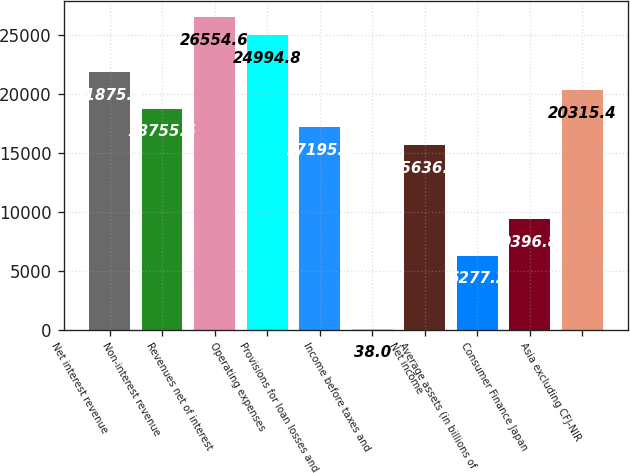Convert chart. <chart><loc_0><loc_0><loc_500><loc_500><bar_chart><fcel>Net interest revenue<fcel>Non-interest revenue<fcel>Revenues net of interest<fcel>Operating expenses<fcel>Provisions for loan losses and<fcel>Income before taxes and<fcel>Net income<fcel>Average assets (in billions of<fcel>Consumer Finance Japan<fcel>Asia excluding CFJ-NIR<nl><fcel>21875.2<fcel>18755.6<fcel>26554.6<fcel>24994.8<fcel>17195.8<fcel>38<fcel>15636<fcel>6277.2<fcel>9396.8<fcel>20315.4<nl></chart> 